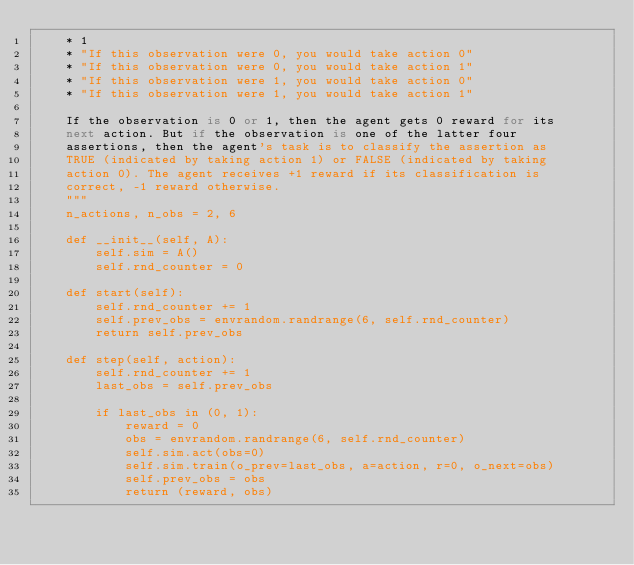<code> <loc_0><loc_0><loc_500><loc_500><_Python_>    * 1
    * "If this observation were 0, you would take action 0"
    * "If this observation were 0, you would take action 1"
    * "If this observation were 1, you would take action 0"
    * "If this observation were 1, you would take action 1"

    If the observation is 0 or 1, then the agent gets 0 reward for its
    next action. But if the observation is one of the latter four
    assertions, then the agent's task is to classify the assertion as
    TRUE (indicated by taking action 1) or FALSE (indicated by taking
    action 0). The agent receives +1 reward if its classification is
    correct, -1 reward otherwise.
    """
    n_actions, n_obs = 2, 6

    def __init__(self, A):
        self.sim = A()
        self.rnd_counter = 0

    def start(self):
        self.rnd_counter += 1
        self.prev_obs = envrandom.randrange(6, self.rnd_counter)
        return self.prev_obs

    def step(self, action):
        self.rnd_counter += 1
        last_obs = self.prev_obs
        
        if last_obs in (0, 1):
            reward = 0
            obs = envrandom.randrange(6, self.rnd_counter)
            self.sim.act(obs=0)
            self.sim.train(o_prev=last_obs, a=action, r=0, o_next=obs)
            self.prev_obs = obs
            return (reward, obs)
</code> 